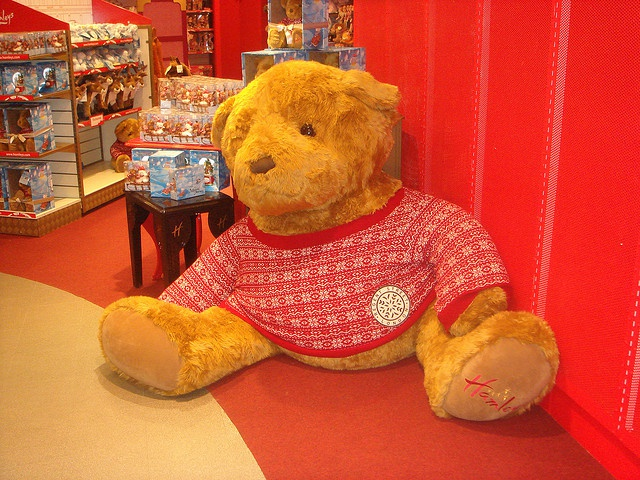Describe the objects in this image and their specific colors. I can see teddy bear in brown, orange, and red tones, dining table in brown, maroon, black, and gray tones, teddy bear in brown, orange, and red tones, and teddy bear in brown, maroon, and red tones in this image. 